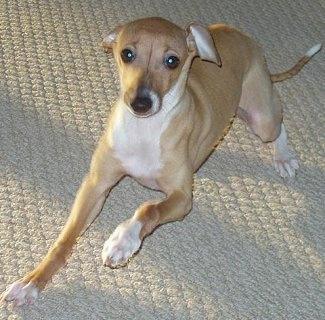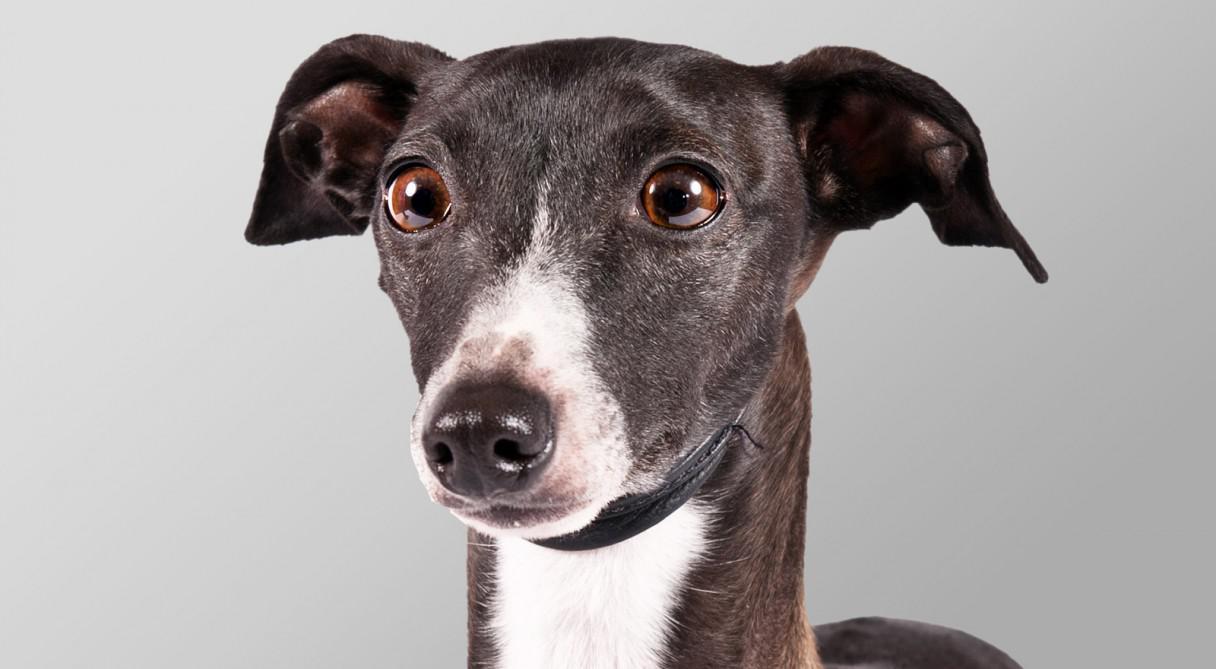The first image is the image on the left, the second image is the image on the right. For the images shown, is this caption "One of the dogs has a collar around its neck." true? Answer yes or no. Yes. The first image is the image on the left, the second image is the image on the right. Analyze the images presented: Is the assertion "An image shows a dog with its tongue sticking out." valid? Answer yes or no. No. 